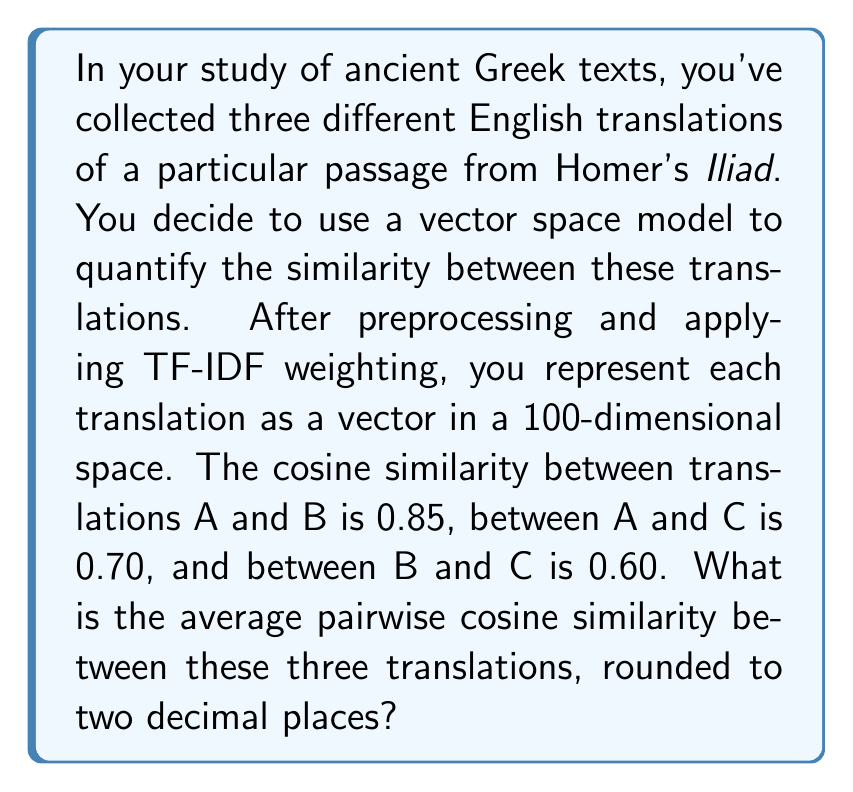Show me your answer to this math problem. Let's approach this step-by-step:

1) We are given three cosine similarity values:
   - sim(A,B) = 0.85
   - sim(A,C) = 0.70
   - sim(B,C) = 0.60

2) To calculate the average pairwise cosine similarity, we need to:
   a) Sum up all the pairwise similarities
   b) Divide by the number of pairs

3) The sum of the similarities is:
   $$ 0.85 + 0.70 + 0.60 = 2.15 $$

4) The number of pairs is 3 (AB, AC, BC)

5) Therefore, the average pairwise cosine similarity is:
   $$ \text{Average} = \frac{2.15}{3} \approx 0.7166667 $$

6) Rounding to two decimal places:
   $$ 0.7166667 \approx 0.72 $$

This result indicates a relatively high degree of similarity among the three translations, which is not unexpected given that they are all based on the same original text.
Answer: 0.72 